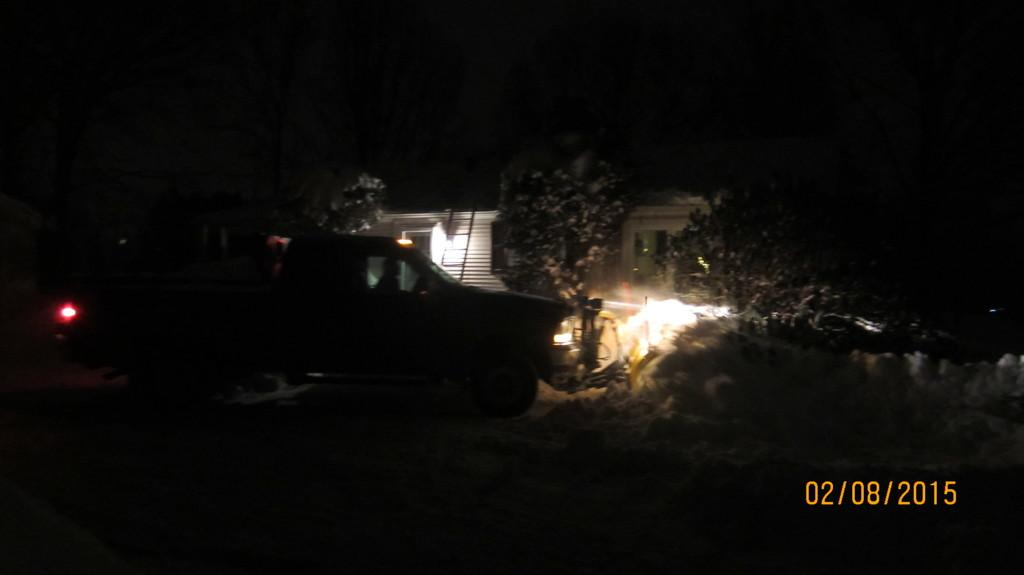What type of vehicle is in the image? The facts provided do not specify the type of vehicle in the image. What structure can be seen in the image? There is a building in the image. What object is used for climbing in the image? There is a ladder in the image. What source of illumination is present in the image? There is a light in the image. What type of vegetation is in the image? There is grass in the image. What type of plant is in the image? There is a tree in the image. Is there any text or logo overlaid on the image? Yes, there is a watermark in the image. What type of curtain is hanging from the tree in the image? There is no curtain present in the image; it features a vehicle, a building, a ladder, a light, grass, a tree, and a watermark. 